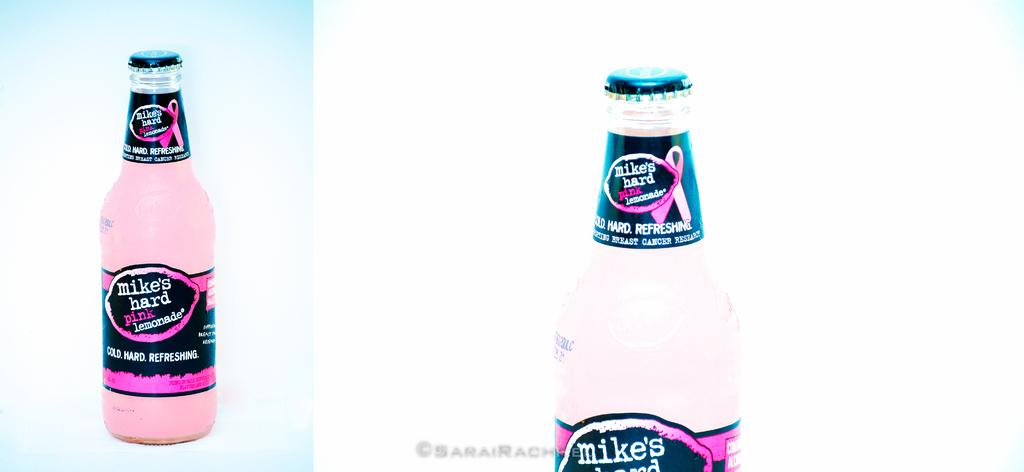<image>
Relay a brief, clear account of the picture shown. A bottles of Mikes Hard Lemonade pays tribute to breast cancer 